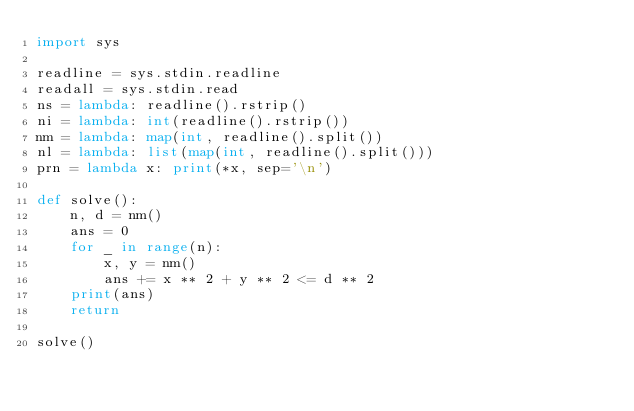Convert code to text. <code><loc_0><loc_0><loc_500><loc_500><_Python_>import sys

readline = sys.stdin.readline
readall = sys.stdin.read
ns = lambda: readline().rstrip()
ni = lambda: int(readline().rstrip())
nm = lambda: map(int, readline().split())
nl = lambda: list(map(int, readline().split()))
prn = lambda x: print(*x, sep='\n')

def solve():
    n, d = nm()
    ans = 0
    for _ in range(n):
        x, y = nm()
        ans += x ** 2 + y ** 2 <= d ** 2
    print(ans)
    return

solve()
</code> 